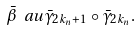Convert formula to latex. <formula><loc_0><loc_0><loc_500><loc_500>\bar { \beta } \ a u \bar { \gamma } _ { 2 k _ { n } + 1 } \circ \bar { \gamma } _ { 2 k _ { n } } .</formula> 